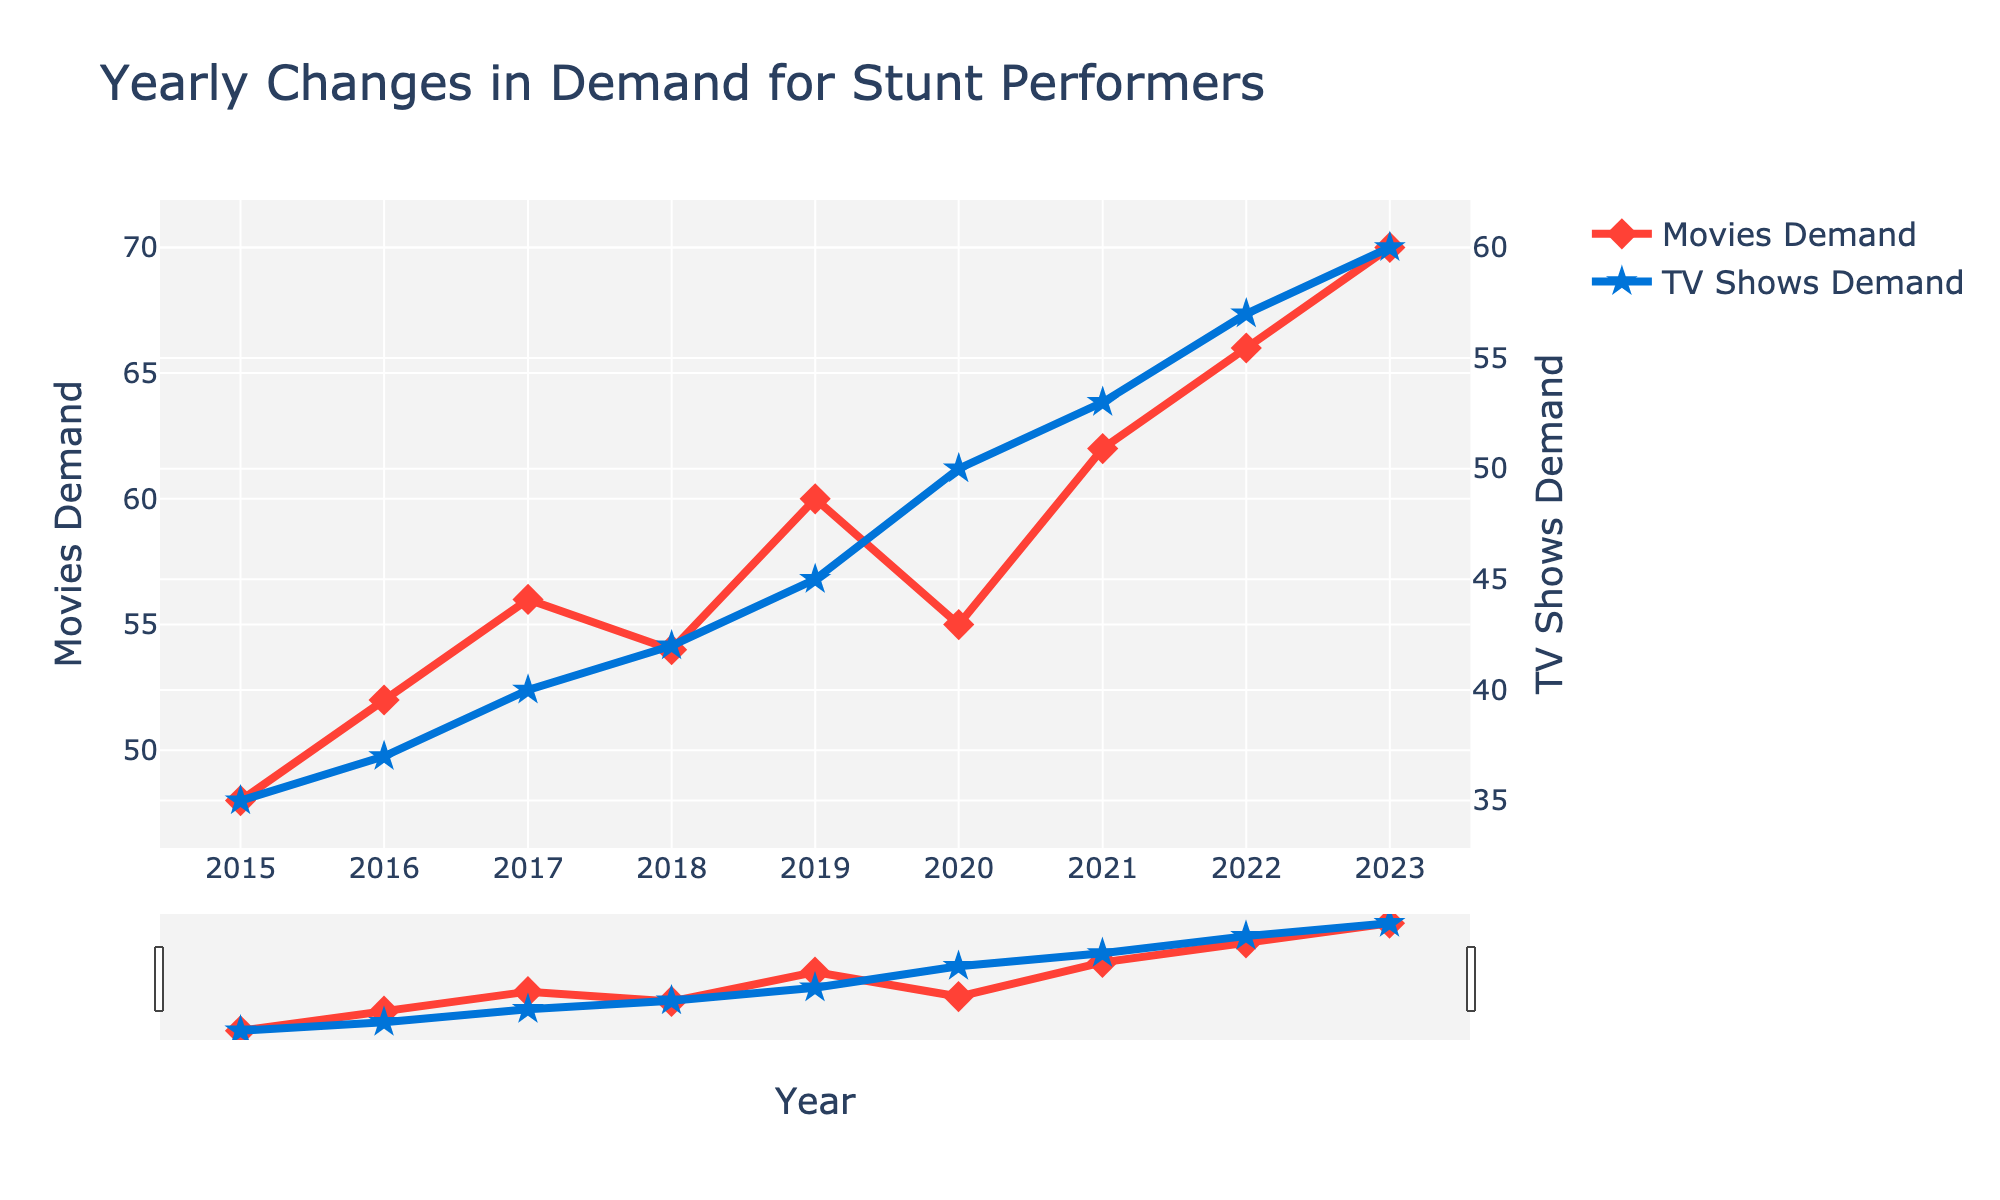What's the title of the plot? The title is located at the top of the figure, and it provides an overview of what the plot represents. From the visual information, the title is "Yearly Changes in Demand for Stunt Performers".
Answer: Yearly Changes in Demand for Stunt Performers What is the demand for stunt performers in TV shows in 2019? To find the demand in a specific year, look for the year on the x-axis and then follow the plot line for TV Shows Demand (blue line with star markers) vertically upward/downward until it intersects with the y-axis on the right. In 2019, TV Shows Demand is 45.
Answer: 45 Between which years did the demand for stunt performers in movies show a decrease? Look at the Movies Demand line (red line with diamond markers) and identify the years the line slopes downward. The demand decreased from 2017 to 2018 and from 2019 to 2020.
Answer: 2017 to 2018 and 2019 to 2020 What was the difference in the demand for stunt performers between movies and TV shows in 2022? For 2022, note the demand values for both Movies (66) and TV Shows (57). Subtract the TV Shows Demand from the Movies Demand: 66 - 57 = 9.
Answer: 9 Which year had the highest demand for stunt performers in movies? Examine the Movies Demand line (red line with diamond markers) and find the peak value on the y-axis aligned with the year. The highest demand is in 2023.
Answer: 2023 Compare the trend in demand for stunt performers in movies and TV shows from 2015 to 2023. Observe the slopes of both lines over time. Both show an upward trend overall, although the Movies Demand line has minor drops between 2017-2018 and 2019-2020, while the TV Shows Demand line consistently rises.
Answer: Both increased, Movies with minor drops, TV Shows consistently up What was the average yearly demand for stunt performers in TV shows from 2015 to 2023? Sum the demands for each year: 35 + 37 + 40 + 42 + 45 + 50 + 53 + 57 + 60 = 419. Divide by the number of years (9): 419 / 9 ≈ 46.56.
Answer: 46.56 In which year did the demand for stunt performers in TV shows surpass 50 for the first time? Follow the TV Shows Demand line (blue line with star markers) and identify the year it first rises above 50, which happens in 2020.
Answer: 2020 